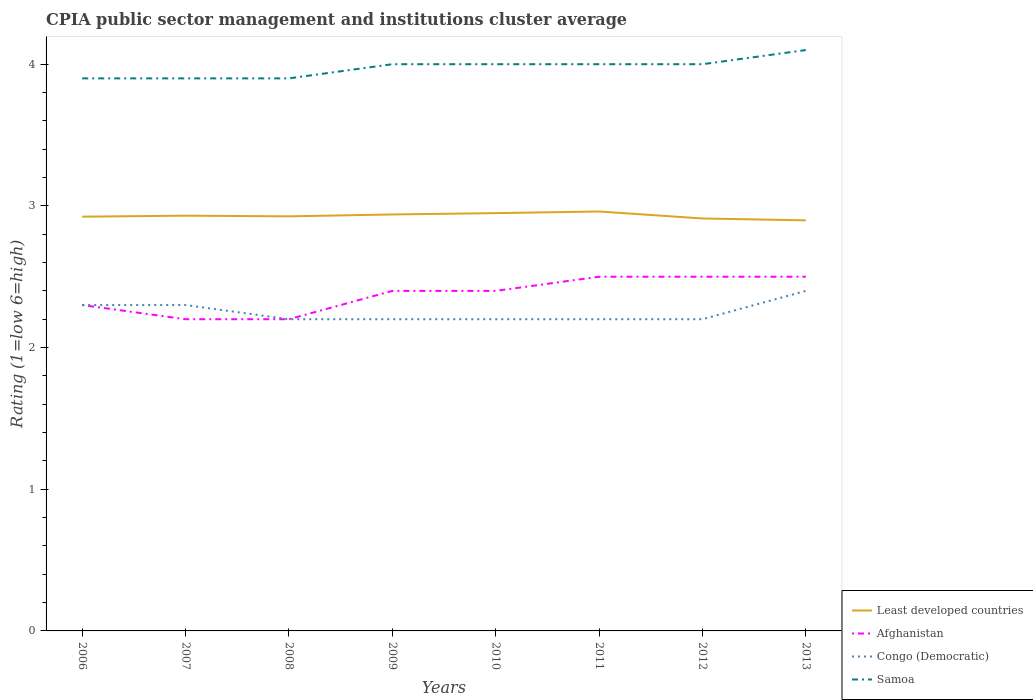How many different coloured lines are there?
Your response must be concise. 4. Is the number of lines equal to the number of legend labels?
Provide a succinct answer. Yes. Across all years, what is the maximum CPIA rating in Samoa?
Your answer should be compact. 3.9. In which year was the CPIA rating in Least developed countries maximum?
Make the answer very short. 2013. What is the total CPIA rating in Samoa in the graph?
Your answer should be very brief. -0.2. What is the difference between the highest and the second highest CPIA rating in Afghanistan?
Provide a short and direct response. 0.3. What is the difference between the highest and the lowest CPIA rating in Samoa?
Offer a very short reply. 5. Does the graph contain grids?
Keep it short and to the point. No. What is the title of the graph?
Keep it short and to the point. CPIA public sector management and institutions cluster average. Does "Kenya" appear as one of the legend labels in the graph?
Keep it short and to the point. No. What is the label or title of the X-axis?
Your response must be concise. Years. What is the label or title of the Y-axis?
Ensure brevity in your answer.  Rating (1=low 6=high). What is the Rating (1=low 6=high) in Least developed countries in 2006?
Your answer should be compact. 2.92. What is the Rating (1=low 6=high) in Afghanistan in 2006?
Offer a terse response. 2.3. What is the Rating (1=low 6=high) in Least developed countries in 2007?
Your response must be concise. 2.93. What is the Rating (1=low 6=high) of Afghanistan in 2007?
Make the answer very short. 2.2. What is the Rating (1=low 6=high) in Samoa in 2007?
Give a very brief answer. 3.9. What is the Rating (1=low 6=high) of Least developed countries in 2008?
Provide a succinct answer. 2.93. What is the Rating (1=low 6=high) of Afghanistan in 2008?
Provide a succinct answer. 2.2. What is the Rating (1=low 6=high) of Congo (Democratic) in 2008?
Your answer should be compact. 2.2. What is the Rating (1=low 6=high) in Samoa in 2008?
Offer a terse response. 3.9. What is the Rating (1=low 6=high) in Least developed countries in 2009?
Provide a short and direct response. 2.94. What is the Rating (1=low 6=high) in Afghanistan in 2009?
Give a very brief answer. 2.4. What is the Rating (1=low 6=high) of Samoa in 2009?
Ensure brevity in your answer.  4. What is the Rating (1=low 6=high) of Least developed countries in 2010?
Keep it short and to the point. 2.95. What is the Rating (1=low 6=high) of Afghanistan in 2010?
Make the answer very short. 2.4. What is the Rating (1=low 6=high) of Congo (Democratic) in 2010?
Your answer should be very brief. 2.2. What is the Rating (1=low 6=high) of Samoa in 2010?
Your answer should be compact. 4. What is the Rating (1=low 6=high) of Least developed countries in 2011?
Your answer should be very brief. 2.96. What is the Rating (1=low 6=high) of Least developed countries in 2012?
Offer a very short reply. 2.91. What is the Rating (1=low 6=high) in Congo (Democratic) in 2012?
Keep it short and to the point. 2.2. What is the Rating (1=low 6=high) of Least developed countries in 2013?
Provide a succinct answer. 2.9. What is the Rating (1=low 6=high) of Afghanistan in 2013?
Offer a terse response. 2.5. What is the Rating (1=low 6=high) in Congo (Democratic) in 2013?
Ensure brevity in your answer.  2.4. What is the Rating (1=low 6=high) in Samoa in 2013?
Your answer should be compact. 4.1. Across all years, what is the maximum Rating (1=low 6=high) of Least developed countries?
Make the answer very short. 2.96. Across all years, what is the maximum Rating (1=low 6=high) of Afghanistan?
Offer a terse response. 2.5. Across all years, what is the maximum Rating (1=low 6=high) in Congo (Democratic)?
Keep it short and to the point. 2.4. Across all years, what is the minimum Rating (1=low 6=high) of Least developed countries?
Give a very brief answer. 2.9. Across all years, what is the minimum Rating (1=low 6=high) in Congo (Democratic)?
Your answer should be compact. 2.2. Across all years, what is the minimum Rating (1=low 6=high) of Samoa?
Make the answer very short. 3.9. What is the total Rating (1=low 6=high) in Least developed countries in the graph?
Ensure brevity in your answer.  23.44. What is the total Rating (1=low 6=high) in Congo (Democratic) in the graph?
Your answer should be compact. 18. What is the total Rating (1=low 6=high) of Samoa in the graph?
Provide a succinct answer. 31.8. What is the difference between the Rating (1=low 6=high) of Least developed countries in 2006 and that in 2007?
Offer a terse response. -0.01. What is the difference between the Rating (1=low 6=high) of Samoa in 2006 and that in 2007?
Ensure brevity in your answer.  0. What is the difference between the Rating (1=low 6=high) in Least developed countries in 2006 and that in 2008?
Make the answer very short. -0. What is the difference between the Rating (1=low 6=high) of Afghanistan in 2006 and that in 2008?
Your answer should be compact. 0.1. What is the difference between the Rating (1=low 6=high) of Samoa in 2006 and that in 2008?
Provide a succinct answer. 0. What is the difference between the Rating (1=low 6=high) in Least developed countries in 2006 and that in 2009?
Ensure brevity in your answer.  -0.02. What is the difference between the Rating (1=low 6=high) of Samoa in 2006 and that in 2009?
Your response must be concise. -0.1. What is the difference between the Rating (1=low 6=high) in Least developed countries in 2006 and that in 2010?
Your response must be concise. -0.03. What is the difference between the Rating (1=low 6=high) in Congo (Democratic) in 2006 and that in 2010?
Provide a succinct answer. 0.1. What is the difference between the Rating (1=low 6=high) in Samoa in 2006 and that in 2010?
Offer a terse response. -0.1. What is the difference between the Rating (1=low 6=high) in Least developed countries in 2006 and that in 2011?
Provide a succinct answer. -0.04. What is the difference between the Rating (1=low 6=high) of Congo (Democratic) in 2006 and that in 2011?
Your answer should be compact. 0.1. What is the difference between the Rating (1=low 6=high) of Samoa in 2006 and that in 2011?
Your answer should be compact. -0.1. What is the difference between the Rating (1=low 6=high) of Least developed countries in 2006 and that in 2012?
Provide a short and direct response. 0.01. What is the difference between the Rating (1=low 6=high) of Congo (Democratic) in 2006 and that in 2012?
Your answer should be very brief. 0.1. What is the difference between the Rating (1=low 6=high) of Samoa in 2006 and that in 2012?
Make the answer very short. -0.1. What is the difference between the Rating (1=low 6=high) in Least developed countries in 2006 and that in 2013?
Your response must be concise. 0.03. What is the difference between the Rating (1=low 6=high) of Afghanistan in 2006 and that in 2013?
Make the answer very short. -0.2. What is the difference between the Rating (1=low 6=high) in Least developed countries in 2007 and that in 2008?
Ensure brevity in your answer.  0. What is the difference between the Rating (1=low 6=high) in Afghanistan in 2007 and that in 2008?
Make the answer very short. 0. What is the difference between the Rating (1=low 6=high) in Congo (Democratic) in 2007 and that in 2008?
Your answer should be compact. 0.1. What is the difference between the Rating (1=low 6=high) of Samoa in 2007 and that in 2008?
Keep it short and to the point. 0. What is the difference between the Rating (1=low 6=high) of Least developed countries in 2007 and that in 2009?
Offer a very short reply. -0.01. What is the difference between the Rating (1=low 6=high) of Congo (Democratic) in 2007 and that in 2009?
Your response must be concise. 0.1. What is the difference between the Rating (1=low 6=high) of Least developed countries in 2007 and that in 2010?
Offer a very short reply. -0.02. What is the difference between the Rating (1=low 6=high) of Afghanistan in 2007 and that in 2010?
Provide a succinct answer. -0.2. What is the difference between the Rating (1=low 6=high) of Least developed countries in 2007 and that in 2011?
Your answer should be very brief. -0.03. What is the difference between the Rating (1=low 6=high) of Congo (Democratic) in 2007 and that in 2011?
Your answer should be compact. 0.1. What is the difference between the Rating (1=low 6=high) in Samoa in 2007 and that in 2011?
Your answer should be compact. -0.1. What is the difference between the Rating (1=low 6=high) in Least developed countries in 2007 and that in 2012?
Make the answer very short. 0.02. What is the difference between the Rating (1=low 6=high) in Least developed countries in 2007 and that in 2013?
Offer a terse response. 0.03. What is the difference between the Rating (1=low 6=high) in Afghanistan in 2007 and that in 2013?
Keep it short and to the point. -0.3. What is the difference between the Rating (1=low 6=high) of Congo (Democratic) in 2007 and that in 2013?
Your response must be concise. -0.1. What is the difference between the Rating (1=low 6=high) in Samoa in 2007 and that in 2013?
Your response must be concise. -0.2. What is the difference between the Rating (1=low 6=high) of Least developed countries in 2008 and that in 2009?
Offer a very short reply. -0.01. What is the difference between the Rating (1=low 6=high) in Afghanistan in 2008 and that in 2009?
Give a very brief answer. -0.2. What is the difference between the Rating (1=low 6=high) of Samoa in 2008 and that in 2009?
Offer a terse response. -0.1. What is the difference between the Rating (1=low 6=high) in Least developed countries in 2008 and that in 2010?
Provide a short and direct response. -0.02. What is the difference between the Rating (1=low 6=high) of Congo (Democratic) in 2008 and that in 2010?
Offer a terse response. 0. What is the difference between the Rating (1=low 6=high) in Samoa in 2008 and that in 2010?
Your answer should be compact. -0.1. What is the difference between the Rating (1=low 6=high) of Least developed countries in 2008 and that in 2011?
Make the answer very short. -0.03. What is the difference between the Rating (1=low 6=high) of Least developed countries in 2008 and that in 2012?
Provide a succinct answer. 0.02. What is the difference between the Rating (1=low 6=high) of Afghanistan in 2008 and that in 2012?
Ensure brevity in your answer.  -0.3. What is the difference between the Rating (1=low 6=high) in Congo (Democratic) in 2008 and that in 2012?
Your response must be concise. 0. What is the difference between the Rating (1=low 6=high) in Least developed countries in 2008 and that in 2013?
Offer a terse response. 0.03. What is the difference between the Rating (1=low 6=high) in Afghanistan in 2008 and that in 2013?
Provide a short and direct response. -0.3. What is the difference between the Rating (1=low 6=high) in Samoa in 2008 and that in 2013?
Your response must be concise. -0.2. What is the difference between the Rating (1=low 6=high) of Least developed countries in 2009 and that in 2010?
Your answer should be compact. -0.01. What is the difference between the Rating (1=low 6=high) of Congo (Democratic) in 2009 and that in 2010?
Ensure brevity in your answer.  0. What is the difference between the Rating (1=low 6=high) of Least developed countries in 2009 and that in 2011?
Offer a very short reply. -0.02. What is the difference between the Rating (1=low 6=high) of Afghanistan in 2009 and that in 2011?
Your response must be concise. -0.1. What is the difference between the Rating (1=low 6=high) in Congo (Democratic) in 2009 and that in 2011?
Your answer should be very brief. 0. What is the difference between the Rating (1=low 6=high) in Least developed countries in 2009 and that in 2012?
Your answer should be compact. 0.03. What is the difference between the Rating (1=low 6=high) of Congo (Democratic) in 2009 and that in 2012?
Offer a terse response. 0. What is the difference between the Rating (1=low 6=high) of Least developed countries in 2009 and that in 2013?
Keep it short and to the point. 0.04. What is the difference between the Rating (1=low 6=high) in Congo (Democratic) in 2009 and that in 2013?
Give a very brief answer. -0.2. What is the difference between the Rating (1=low 6=high) of Least developed countries in 2010 and that in 2011?
Your answer should be very brief. -0.01. What is the difference between the Rating (1=low 6=high) in Samoa in 2010 and that in 2011?
Ensure brevity in your answer.  0. What is the difference between the Rating (1=low 6=high) in Least developed countries in 2010 and that in 2012?
Keep it short and to the point. 0.04. What is the difference between the Rating (1=low 6=high) in Afghanistan in 2010 and that in 2012?
Your answer should be very brief. -0.1. What is the difference between the Rating (1=low 6=high) in Congo (Democratic) in 2010 and that in 2012?
Keep it short and to the point. 0. What is the difference between the Rating (1=low 6=high) in Samoa in 2010 and that in 2012?
Your response must be concise. 0. What is the difference between the Rating (1=low 6=high) in Least developed countries in 2010 and that in 2013?
Make the answer very short. 0.05. What is the difference between the Rating (1=low 6=high) of Samoa in 2010 and that in 2013?
Make the answer very short. -0.1. What is the difference between the Rating (1=low 6=high) of Least developed countries in 2011 and that in 2012?
Offer a terse response. 0.05. What is the difference between the Rating (1=low 6=high) in Afghanistan in 2011 and that in 2012?
Provide a succinct answer. 0. What is the difference between the Rating (1=low 6=high) of Congo (Democratic) in 2011 and that in 2012?
Your response must be concise. 0. What is the difference between the Rating (1=low 6=high) in Samoa in 2011 and that in 2012?
Your answer should be compact. 0. What is the difference between the Rating (1=low 6=high) of Least developed countries in 2011 and that in 2013?
Provide a succinct answer. 0.06. What is the difference between the Rating (1=low 6=high) of Afghanistan in 2011 and that in 2013?
Make the answer very short. 0. What is the difference between the Rating (1=low 6=high) of Samoa in 2011 and that in 2013?
Your answer should be compact. -0.1. What is the difference between the Rating (1=low 6=high) of Least developed countries in 2012 and that in 2013?
Offer a terse response. 0.01. What is the difference between the Rating (1=low 6=high) of Afghanistan in 2012 and that in 2013?
Provide a short and direct response. 0. What is the difference between the Rating (1=low 6=high) in Congo (Democratic) in 2012 and that in 2013?
Your answer should be very brief. -0.2. What is the difference between the Rating (1=low 6=high) in Least developed countries in 2006 and the Rating (1=low 6=high) in Afghanistan in 2007?
Offer a very short reply. 0.72. What is the difference between the Rating (1=low 6=high) in Least developed countries in 2006 and the Rating (1=low 6=high) in Congo (Democratic) in 2007?
Offer a very short reply. 0.62. What is the difference between the Rating (1=low 6=high) of Least developed countries in 2006 and the Rating (1=low 6=high) of Samoa in 2007?
Give a very brief answer. -0.98. What is the difference between the Rating (1=low 6=high) of Congo (Democratic) in 2006 and the Rating (1=low 6=high) of Samoa in 2007?
Your response must be concise. -1.6. What is the difference between the Rating (1=low 6=high) in Least developed countries in 2006 and the Rating (1=low 6=high) in Afghanistan in 2008?
Give a very brief answer. 0.72. What is the difference between the Rating (1=low 6=high) in Least developed countries in 2006 and the Rating (1=low 6=high) in Congo (Democratic) in 2008?
Your response must be concise. 0.72. What is the difference between the Rating (1=low 6=high) in Least developed countries in 2006 and the Rating (1=low 6=high) in Samoa in 2008?
Your answer should be very brief. -0.98. What is the difference between the Rating (1=low 6=high) of Afghanistan in 2006 and the Rating (1=low 6=high) of Samoa in 2008?
Your answer should be very brief. -1.6. What is the difference between the Rating (1=low 6=high) of Least developed countries in 2006 and the Rating (1=low 6=high) of Afghanistan in 2009?
Give a very brief answer. 0.52. What is the difference between the Rating (1=low 6=high) of Least developed countries in 2006 and the Rating (1=low 6=high) of Congo (Democratic) in 2009?
Make the answer very short. 0.72. What is the difference between the Rating (1=low 6=high) of Least developed countries in 2006 and the Rating (1=low 6=high) of Samoa in 2009?
Offer a terse response. -1.08. What is the difference between the Rating (1=low 6=high) of Afghanistan in 2006 and the Rating (1=low 6=high) of Congo (Democratic) in 2009?
Keep it short and to the point. 0.1. What is the difference between the Rating (1=low 6=high) of Afghanistan in 2006 and the Rating (1=low 6=high) of Samoa in 2009?
Offer a terse response. -1.7. What is the difference between the Rating (1=low 6=high) in Congo (Democratic) in 2006 and the Rating (1=low 6=high) in Samoa in 2009?
Your answer should be compact. -1.7. What is the difference between the Rating (1=low 6=high) in Least developed countries in 2006 and the Rating (1=low 6=high) in Afghanistan in 2010?
Give a very brief answer. 0.52. What is the difference between the Rating (1=low 6=high) in Least developed countries in 2006 and the Rating (1=low 6=high) in Congo (Democratic) in 2010?
Provide a short and direct response. 0.72. What is the difference between the Rating (1=low 6=high) in Least developed countries in 2006 and the Rating (1=low 6=high) in Samoa in 2010?
Provide a succinct answer. -1.08. What is the difference between the Rating (1=low 6=high) in Afghanistan in 2006 and the Rating (1=low 6=high) in Congo (Democratic) in 2010?
Ensure brevity in your answer.  0.1. What is the difference between the Rating (1=low 6=high) of Afghanistan in 2006 and the Rating (1=low 6=high) of Samoa in 2010?
Your answer should be compact. -1.7. What is the difference between the Rating (1=low 6=high) of Congo (Democratic) in 2006 and the Rating (1=low 6=high) of Samoa in 2010?
Offer a very short reply. -1.7. What is the difference between the Rating (1=low 6=high) of Least developed countries in 2006 and the Rating (1=low 6=high) of Afghanistan in 2011?
Make the answer very short. 0.42. What is the difference between the Rating (1=low 6=high) in Least developed countries in 2006 and the Rating (1=low 6=high) in Congo (Democratic) in 2011?
Your answer should be compact. 0.72. What is the difference between the Rating (1=low 6=high) in Least developed countries in 2006 and the Rating (1=low 6=high) in Samoa in 2011?
Ensure brevity in your answer.  -1.08. What is the difference between the Rating (1=low 6=high) of Afghanistan in 2006 and the Rating (1=low 6=high) of Congo (Democratic) in 2011?
Provide a short and direct response. 0.1. What is the difference between the Rating (1=low 6=high) in Afghanistan in 2006 and the Rating (1=low 6=high) in Samoa in 2011?
Offer a terse response. -1.7. What is the difference between the Rating (1=low 6=high) of Least developed countries in 2006 and the Rating (1=low 6=high) of Afghanistan in 2012?
Make the answer very short. 0.42. What is the difference between the Rating (1=low 6=high) in Least developed countries in 2006 and the Rating (1=low 6=high) in Congo (Democratic) in 2012?
Offer a terse response. 0.72. What is the difference between the Rating (1=low 6=high) in Least developed countries in 2006 and the Rating (1=low 6=high) in Samoa in 2012?
Provide a short and direct response. -1.08. What is the difference between the Rating (1=low 6=high) in Afghanistan in 2006 and the Rating (1=low 6=high) in Congo (Democratic) in 2012?
Your response must be concise. 0.1. What is the difference between the Rating (1=low 6=high) of Least developed countries in 2006 and the Rating (1=low 6=high) of Afghanistan in 2013?
Your answer should be very brief. 0.42. What is the difference between the Rating (1=low 6=high) in Least developed countries in 2006 and the Rating (1=low 6=high) in Congo (Democratic) in 2013?
Provide a short and direct response. 0.52. What is the difference between the Rating (1=low 6=high) in Least developed countries in 2006 and the Rating (1=low 6=high) in Samoa in 2013?
Make the answer very short. -1.18. What is the difference between the Rating (1=low 6=high) of Afghanistan in 2006 and the Rating (1=low 6=high) of Congo (Democratic) in 2013?
Offer a terse response. -0.1. What is the difference between the Rating (1=low 6=high) in Afghanistan in 2006 and the Rating (1=low 6=high) in Samoa in 2013?
Your response must be concise. -1.8. What is the difference between the Rating (1=low 6=high) in Congo (Democratic) in 2006 and the Rating (1=low 6=high) in Samoa in 2013?
Keep it short and to the point. -1.8. What is the difference between the Rating (1=low 6=high) of Least developed countries in 2007 and the Rating (1=low 6=high) of Afghanistan in 2008?
Your answer should be compact. 0.73. What is the difference between the Rating (1=low 6=high) in Least developed countries in 2007 and the Rating (1=low 6=high) in Congo (Democratic) in 2008?
Your response must be concise. 0.73. What is the difference between the Rating (1=low 6=high) of Least developed countries in 2007 and the Rating (1=low 6=high) of Samoa in 2008?
Ensure brevity in your answer.  -0.97. What is the difference between the Rating (1=low 6=high) in Afghanistan in 2007 and the Rating (1=low 6=high) in Samoa in 2008?
Ensure brevity in your answer.  -1.7. What is the difference between the Rating (1=low 6=high) in Congo (Democratic) in 2007 and the Rating (1=low 6=high) in Samoa in 2008?
Your answer should be compact. -1.6. What is the difference between the Rating (1=low 6=high) in Least developed countries in 2007 and the Rating (1=low 6=high) in Afghanistan in 2009?
Your answer should be very brief. 0.53. What is the difference between the Rating (1=low 6=high) of Least developed countries in 2007 and the Rating (1=low 6=high) of Congo (Democratic) in 2009?
Offer a very short reply. 0.73. What is the difference between the Rating (1=low 6=high) of Least developed countries in 2007 and the Rating (1=low 6=high) of Samoa in 2009?
Provide a succinct answer. -1.07. What is the difference between the Rating (1=low 6=high) of Afghanistan in 2007 and the Rating (1=low 6=high) of Congo (Democratic) in 2009?
Offer a very short reply. 0. What is the difference between the Rating (1=low 6=high) of Afghanistan in 2007 and the Rating (1=low 6=high) of Samoa in 2009?
Ensure brevity in your answer.  -1.8. What is the difference between the Rating (1=low 6=high) of Least developed countries in 2007 and the Rating (1=low 6=high) of Afghanistan in 2010?
Your answer should be very brief. 0.53. What is the difference between the Rating (1=low 6=high) in Least developed countries in 2007 and the Rating (1=low 6=high) in Congo (Democratic) in 2010?
Give a very brief answer. 0.73. What is the difference between the Rating (1=low 6=high) of Least developed countries in 2007 and the Rating (1=low 6=high) of Samoa in 2010?
Give a very brief answer. -1.07. What is the difference between the Rating (1=low 6=high) in Afghanistan in 2007 and the Rating (1=low 6=high) in Samoa in 2010?
Offer a terse response. -1.8. What is the difference between the Rating (1=low 6=high) in Congo (Democratic) in 2007 and the Rating (1=low 6=high) in Samoa in 2010?
Your answer should be very brief. -1.7. What is the difference between the Rating (1=low 6=high) of Least developed countries in 2007 and the Rating (1=low 6=high) of Afghanistan in 2011?
Your answer should be compact. 0.43. What is the difference between the Rating (1=low 6=high) in Least developed countries in 2007 and the Rating (1=low 6=high) in Congo (Democratic) in 2011?
Your answer should be compact. 0.73. What is the difference between the Rating (1=low 6=high) in Least developed countries in 2007 and the Rating (1=low 6=high) in Samoa in 2011?
Provide a succinct answer. -1.07. What is the difference between the Rating (1=low 6=high) in Afghanistan in 2007 and the Rating (1=low 6=high) in Congo (Democratic) in 2011?
Your response must be concise. 0. What is the difference between the Rating (1=low 6=high) in Afghanistan in 2007 and the Rating (1=low 6=high) in Samoa in 2011?
Ensure brevity in your answer.  -1.8. What is the difference between the Rating (1=low 6=high) of Least developed countries in 2007 and the Rating (1=low 6=high) of Afghanistan in 2012?
Offer a terse response. 0.43. What is the difference between the Rating (1=low 6=high) of Least developed countries in 2007 and the Rating (1=low 6=high) of Congo (Democratic) in 2012?
Your response must be concise. 0.73. What is the difference between the Rating (1=low 6=high) in Least developed countries in 2007 and the Rating (1=low 6=high) in Samoa in 2012?
Your response must be concise. -1.07. What is the difference between the Rating (1=low 6=high) of Afghanistan in 2007 and the Rating (1=low 6=high) of Samoa in 2012?
Make the answer very short. -1.8. What is the difference between the Rating (1=low 6=high) in Congo (Democratic) in 2007 and the Rating (1=low 6=high) in Samoa in 2012?
Give a very brief answer. -1.7. What is the difference between the Rating (1=low 6=high) of Least developed countries in 2007 and the Rating (1=low 6=high) of Afghanistan in 2013?
Give a very brief answer. 0.43. What is the difference between the Rating (1=low 6=high) of Least developed countries in 2007 and the Rating (1=low 6=high) of Congo (Democratic) in 2013?
Offer a terse response. 0.53. What is the difference between the Rating (1=low 6=high) of Least developed countries in 2007 and the Rating (1=low 6=high) of Samoa in 2013?
Give a very brief answer. -1.17. What is the difference between the Rating (1=low 6=high) in Afghanistan in 2007 and the Rating (1=low 6=high) in Congo (Democratic) in 2013?
Make the answer very short. -0.2. What is the difference between the Rating (1=low 6=high) in Least developed countries in 2008 and the Rating (1=low 6=high) in Afghanistan in 2009?
Make the answer very short. 0.53. What is the difference between the Rating (1=low 6=high) in Least developed countries in 2008 and the Rating (1=low 6=high) in Congo (Democratic) in 2009?
Give a very brief answer. 0.73. What is the difference between the Rating (1=low 6=high) in Least developed countries in 2008 and the Rating (1=low 6=high) in Samoa in 2009?
Offer a terse response. -1.07. What is the difference between the Rating (1=low 6=high) of Afghanistan in 2008 and the Rating (1=low 6=high) of Congo (Democratic) in 2009?
Your answer should be very brief. 0. What is the difference between the Rating (1=low 6=high) of Least developed countries in 2008 and the Rating (1=low 6=high) of Afghanistan in 2010?
Ensure brevity in your answer.  0.53. What is the difference between the Rating (1=low 6=high) of Least developed countries in 2008 and the Rating (1=low 6=high) of Congo (Democratic) in 2010?
Your answer should be compact. 0.73. What is the difference between the Rating (1=low 6=high) in Least developed countries in 2008 and the Rating (1=low 6=high) in Samoa in 2010?
Give a very brief answer. -1.07. What is the difference between the Rating (1=low 6=high) of Afghanistan in 2008 and the Rating (1=low 6=high) of Congo (Democratic) in 2010?
Your answer should be very brief. 0. What is the difference between the Rating (1=low 6=high) in Least developed countries in 2008 and the Rating (1=low 6=high) in Afghanistan in 2011?
Your response must be concise. 0.43. What is the difference between the Rating (1=low 6=high) of Least developed countries in 2008 and the Rating (1=low 6=high) of Congo (Democratic) in 2011?
Provide a succinct answer. 0.73. What is the difference between the Rating (1=low 6=high) of Least developed countries in 2008 and the Rating (1=low 6=high) of Samoa in 2011?
Provide a succinct answer. -1.07. What is the difference between the Rating (1=low 6=high) of Afghanistan in 2008 and the Rating (1=low 6=high) of Congo (Democratic) in 2011?
Your answer should be very brief. 0. What is the difference between the Rating (1=low 6=high) in Least developed countries in 2008 and the Rating (1=low 6=high) in Afghanistan in 2012?
Ensure brevity in your answer.  0.43. What is the difference between the Rating (1=low 6=high) in Least developed countries in 2008 and the Rating (1=low 6=high) in Congo (Democratic) in 2012?
Provide a short and direct response. 0.73. What is the difference between the Rating (1=low 6=high) of Least developed countries in 2008 and the Rating (1=low 6=high) of Samoa in 2012?
Offer a very short reply. -1.07. What is the difference between the Rating (1=low 6=high) in Afghanistan in 2008 and the Rating (1=low 6=high) in Congo (Democratic) in 2012?
Ensure brevity in your answer.  0. What is the difference between the Rating (1=low 6=high) in Congo (Democratic) in 2008 and the Rating (1=low 6=high) in Samoa in 2012?
Provide a succinct answer. -1.8. What is the difference between the Rating (1=low 6=high) in Least developed countries in 2008 and the Rating (1=low 6=high) in Afghanistan in 2013?
Ensure brevity in your answer.  0.43. What is the difference between the Rating (1=low 6=high) in Least developed countries in 2008 and the Rating (1=low 6=high) in Congo (Democratic) in 2013?
Your answer should be very brief. 0.53. What is the difference between the Rating (1=low 6=high) of Least developed countries in 2008 and the Rating (1=low 6=high) of Samoa in 2013?
Your answer should be compact. -1.17. What is the difference between the Rating (1=low 6=high) of Least developed countries in 2009 and the Rating (1=low 6=high) of Afghanistan in 2010?
Give a very brief answer. 0.54. What is the difference between the Rating (1=low 6=high) in Least developed countries in 2009 and the Rating (1=low 6=high) in Congo (Democratic) in 2010?
Provide a short and direct response. 0.74. What is the difference between the Rating (1=low 6=high) in Least developed countries in 2009 and the Rating (1=low 6=high) in Samoa in 2010?
Make the answer very short. -1.06. What is the difference between the Rating (1=low 6=high) in Afghanistan in 2009 and the Rating (1=low 6=high) in Samoa in 2010?
Offer a very short reply. -1.6. What is the difference between the Rating (1=low 6=high) in Least developed countries in 2009 and the Rating (1=low 6=high) in Afghanistan in 2011?
Provide a short and direct response. 0.44. What is the difference between the Rating (1=low 6=high) of Least developed countries in 2009 and the Rating (1=low 6=high) of Congo (Democratic) in 2011?
Your answer should be compact. 0.74. What is the difference between the Rating (1=low 6=high) of Least developed countries in 2009 and the Rating (1=low 6=high) of Samoa in 2011?
Provide a short and direct response. -1.06. What is the difference between the Rating (1=low 6=high) of Least developed countries in 2009 and the Rating (1=low 6=high) of Afghanistan in 2012?
Keep it short and to the point. 0.44. What is the difference between the Rating (1=low 6=high) in Least developed countries in 2009 and the Rating (1=low 6=high) in Congo (Democratic) in 2012?
Keep it short and to the point. 0.74. What is the difference between the Rating (1=low 6=high) of Least developed countries in 2009 and the Rating (1=low 6=high) of Samoa in 2012?
Your answer should be compact. -1.06. What is the difference between the Rating (1=low 6=high) of Afghanistan in 2009 and the Rating (1=low 6=high) of Congo (Democratic) in 2012?
Make the answer very short. 0.2. What is the difference between the Rating (1=low 6=high) in Congo (Democratic) in 2009 and the Rating (1=low 6=high) in Samoa in 2012?
Ensure brevity in your answer.  -1.8. What is the difference between the Rating (1=low 6=high) in Least developed countries in 2009 and the Rating (1=low 6=high) in Afghanistan in 2013?
Offer a terse response. 0.44. What is the difference between the Rating (1=low 6=high) of Least developed countries in 2009 and the Rating (1=low 6=high) of Congo (Democratic) in 2013?
Keep it short and to the point. 0.54. What is the difference between the Rating (1=low 6=high) of Least developed countries in 2009 and the Rating (1=low 6=high) of Samoa in 2013?
Your response must be concise. -1.16. What is the difference between the Rating (1=low 6=high) in Afghanistan in 2009 and the Rating (1=low 6=high) in Samoa in 2013?
Keep it short and to the point. -1.7. What is the difference between the Rating (1=low 6=high) in Least developed countries in 2010 and the Rating (1=low 6=high) in Afghanistan in 2011?
Offer a very short reply. 0.45. What is the difference between the Rating (1=low 6=high) in Least developed countries in 2010 and the Rating (1=low 6=high) in Congo (Democratic) in 2011?
Ensure brevity in your answer.  0.75. What is the difference between the Rating (1=low 6=high) in Least developed countries in 2010 and the Rating (1=low 6=high) in Samoa in 2011?
Provide a short and direct response. -1.05. What is the difference between the Rating (1=low 6=high) of Afghanistan in 2010 and the Rating (1=low 6=high) of Congo (Democratic) in 2011?
Provide a succinct answer. 0.2. What is the difference between the Rating (1=low 6=high) in Least developed countries in 2010 and the Rating (1=low 6=high) in Afghanistan in 2012?
Your answer should be very brief. 0.45. What is the difference between the Rating (1=low 6=high) of Least developed countries in 2010 and the Rating (1=low 6=high) of Congo (Democratic) in 2012?
Ensure brevity in your answer.  0.75. What is the difference between the Rating (1=low 6=high) of Least developed countries in 2010 and the Rating (1=low 6=high) of Samoa in 2012?
Ensure brevity in your answer.  -1.05. What is the difference between the Rating (1=low 6=high) in Afghanistan in 2010 and the Rating (1=low 6=high) in Congo (Democratic) in 2012?
Keep it short and to the point. 0.2. What is the difference between the Rating (1=low 6=high) in Congo (Democratic) in 2010 and the Rating (1=low 6=high) in Samoa in 2012?
Give a very brief answer. -1.8. What is the difference between the Rating (1=low 6=high) in Least developed countries in 2010 and the Rating (1=low 6=high) in Afghanistan in 2013?
Provide a short and direct response. 0.45. What is the difference between the Rating (1=low 6=high) in Least developed countries in 2010 and the Rating (1=low 6=high) in Congo (Democratic) in 2013?
Provide a short and direct response. 0.55. What is the difference between the Rating (1=low 6=high) in Least developed countries in 2010 and the Rating (1=low 6=high) in Samoa in 2013?
Offer a very short reply. -1.15. What is the difference between the Rating (1=low 6=high) in Congo (Democratic) in 2010 and the Rating (1=low 6=high) in Samoa in 2013?
Keep it short and to the point. -1.9. What is the difference between the Rating (1=low 6=high) of Least developed countries in 2011 and the Rating (1=low 6=high) of Afghanistan in 2012?
Offer a terse response. 0.46. What is the difference between the Rating (1=low 6=high) of Least developed countries in 2011 and the Rating (1=low 6=high) of Congo (Democratic) in 2012?
Ensure brevity in your answer.  0.76. What is the difference between the Rating (1=low 6=high) of Least developed countries in 2011 and the Rating (1=low 6=high) of Samoa in 2012?
Ensure brevity in your answer.  -1.04. What is the difference between the Rating (1=low 6=high) of Afghanistan in 2011 and the Rating (1=low 6=high) of Samoa in 2012?
Your answer should be very brief. -1.5. What is the difference between the Rating (1=low 6=high) in Congo (Democratic) in 2011 and the Rating (1=low 6=high) in Samoa in 2012?
Keep it short and to the point. -1.8. What is the difference between the Rating (1=low 6=high) in Least developed countries in 2011 and the Rating (1=low 6=high) in Afghanistan in 2013?
Offer a very short reply. 0.46. What is the difference between the Rating (1=low 6=high) in Least developed countries in 2011 and the Rating (1=low 6=high) in Congo (Democratic) in 2013?
Provide a succinct answer. 0.56. What is the difference between the Rating (1=low 6=high) in Least developed countries in 2011 and the Rating (1=low 6=high) in Samoa in 2013?
Make the answer very short. -1.14. What is the difference between the Rating (1=low 6=high) of Afghanistan in 2011 and the Rating (1=low 6=high) of Congo (Democratic) in 2013?
Keep it short and to the point. 0.1. What is the difference between the Rating (1=low 6=high) of Afghanistan in 2011 and the Rating (1=low 6=high) of Samoa in 2013?
Offer a terse response. -1.6. What is the difference between the Rating (1=low 6=high) in Least developed countries in 2012 and the Rating (1=low 6=high) in Afghanistan in 2013?
Offer a very short reply. 0.41. What is the difference between the Rating (1=low 6=high) of Least developed countries in 2012 and the Rating (1=low 6=high) of Congo (Democratic) in 2013?
Your response must be concise. 0.51. What is the difference between the Rating (1=low 6=high) of Least developed countries in 2012 and the Rating (1=low 6=high) of Samoa in 2013?
Provide a short and direct response. -1.19. What is the difference between the Rating (1=low 6=high) of Afghanistan in 2012 and the Rating (1=low 6=high) of Congo (Democratic) in 2013?
Keep it short and to the point. 0.1. What is the average Rating (1=low 6=high) of Least developed countries per year?
Your response must be concise. 2.93. What is the average Rating (1=low 6=high) of Afghanistan per year?
Offer a terse response. 2.38. What is the average Rating (1=low 6=high) of Congo (Democratic) per year?
Provide a short and direct response. 2.25. What is the average Rating (1=low 6=high) in Samoa per year?
Ensure brevity in your answer.  3.98. In the year 2006, what is the difference between the Rating (1=low 6=high) of Least developed countries and Rating (1=low 6=high) of Afghanistan?
Keep it short and to the point. 0.62. In the year 2006, what is the difference between the Rating (1=low 6=high) in Least developed countries and Rating (1=low 6=high) in Congo (Democratic)?
Your answer should be very brief. 0.62. In the year 2006, what is the difference between the Rating (1=low 6=high) of Least developed countries and Rating (1=low 6=high) of Samoa?
Offer a very short reply. -0.98. In the year 2007, what is the difference between the Rating (1=low 6=high) of Least developed countries and Rating (1=low 6=high) of Afghanistan?
Give a very brief answer. 0.73. In the year 2007, what is the difference between the Rating (1=low 6=high) of Least developed countries and Rating (1=low 6=high) of Congo (Democratic)?
Your answer should be very brief. 0.63. In the year 2007, what is the difference between the Rating (1=low 6=high) of Least developed countries and Rating (1=low 6=high) of Samoa?
Your answer should be very brief. -0.97. In the year 2008, what is the difference between the Rating (1=low 6=high) in Least developed countries and Rating (1=low 6=high) in Afghanistan?
Offer a terse response. 0.73. In the year 2008, what is the difference between the Rating (1=low 6=high) in Least developed countries and Rating (1=low 6=high) in Congo (Democratic)?
Offer a very short reply. 0.73. In the year 2008, what is the difference between the Rating (1=low 6=high) in Least developed countries and Rating (1=low 6=high) in Samoa?
Offer a very short reply. -0.97. In the year 2009, what is the difference between the Rating (1=low 6=high) of Least developed countries and Rating (1=low 6=high) of Afghanistan?
Offer a very short reply. 0.54. In the year 2009, what is the difference between the Rating (1=low 6=high) in Least developed countries and Rating (1=low 6=high) in Congo (Democratic)?
Your answer should be very brief. 0.74. In the year 2009, what is the difference between the Rating (1=low 6=high) of Least developed countries and Rating (1=low 6=high) of Samoa?
Ensure brevity in your answer.  -1.06. In the year 2009, what is the difference between the Rating (1=low 6=high) of Afghanistan and Rating (1=low 6=high) of Congo (Democratic)?
Keep it short and to the point. 0.2. In the year 2010, what is the difference between the Rating (1=low 6=high) in Least developed countries and Rating (1=low 6=high) in Afghanistan?
Give a very brief answer. 0.55. In the year 2010, what is the difference between the Rating (1=low 6=high) in Least developed countries and Rating (1=low 6=high) in Congo (Democratic)?
Keep it short and to the point. 0.75. In the year 2010, what is the difference between the Rating (1=low 6=high) in Least developed countries and Rating (1=low 6=high) in Samoa?
Provide a short and direct response. -1.05. In the year 2011, what is the difference between the Rating (1=low 6=high) of Least developed countries and Rating (1=low 6=high) of Afghanistan?
Your response must be concise. 0.46. In the year 2011, what is the difference between the Rating (1=low 6=high) in Least developed countries and Rating (1=low 6=high) in Congo (Democratic)?
Keep it short and to the point. 0.76. In the year 2011, what is the difference between the Rating (1=low 6=high) of Least developed countries and Rating (1=low 6=high) of Samoa?
Provide a short and direct response. -1.04. In the year 2011, what is the difference between the Rating (1=low 6=high) of Afghanistan and Rating (1=low 6=high) of Samoa?
Give a very brief answer. -1.5. In the year 2012, what is the difference between the Rating (1=low 6=high) of Least developed countries and Rating (1=low 6=high) of Afghanistan?
Offer a very short reply. 0.41. In the year 2012, what is the difference between the Rating (1=low 6=high) in Least developed countries and Rating (1=low 6=high) in Congo (Democratic)?
Provide a succinct answer. 0.71. In the year 2012, what is the difference between the Rating (1=low 6=high) in Least developed countries and Rating (1=low 6=high) in Samoa?
Your answer should be compact. -1.09. In the year 2012, what is the difference between the Rating (1=low 6=high) of Congo (Democratic) and Rating (1=low 6=high) of Samoa?
Your response must be concise. -1.8. In the year 2013, what is the difference between the Rating (1=low 6=high) in Least developed countries and Rating (1=low 6=high) in Afghanistan?
Give a very brief answer. 0.4. In the year 2013, what is the difference between the Rating (1=low 6=high) in Least developed countries and Rating (1=low 6=high) in Congo (Democratic)?
Make the answer very short. 0.5. In the year 2013, what is the difference between the Rating (1=low 6=high) of Least developed countries and Rating (1=low 6=high) of Samoa?
Your response must be concise. -1.2. In the year 2013, what is the difference between the Rating (1=low 6=high) in Afghanistan and Rating (1=low 6=high) in Samoa?
Your answer should be very brief. -1.6. In the year 2013, what is the difference between the Rating (1=low 6=high) of Congo (Democratic) and Rating (1=low 6=high) of Samoa?
Give a very brief answer. -1.7. What is the ratio of the Rating (1=low 6=high) of Afghanistan in 2006 to that in 2007?
Provide a short and direct response. 1.05. What is the ratio of the Rating (1=low 6=high) in Congo (Democratic) in 2006 to that in 2007?
Give a very brief answer. 1. What is the ratio of the Rating (1=low 6=high) of Samoa in 2006 to that in 2007?
Keep it short and to the point. 1. What is the ratio of the Rating (1=low 6=high) in Least developed countries in 2006 to that in 2008?
Ensure brevity in your answer.  1. What is the ratio of the Rating (1=low 6=high) in Afghanistan in 2006 to that in 2008?
Offer a terse response. 1.05. What is the ratio of the Rating (1=low 6=high) of Congo (Democratic) in 2006 to that in 2008?
Provide a short and direct response. 1.05. What is the ratio of the Rating (1=low 6=high) of Least developed countries in 2006 to that in 2009?
Give a very brief answer. 0.99. What is the ratio of the Rating (1=low 6=high) in Congo (Democratic) in 2006 to that in 2009?
Make the answer very short. 1.05. What is the ratio of the Rating (1=low 6=high) in Afghanistan in 2006 to that in 2010?
Give a very brief answer. 0.96. What is the ratio of the Rating (1=low 6=high) of Congo (Democratic) in 2006 to that in 2010?
Offer a very short reply. 1.05. What is the ratio of the Rating (1=low 6=high) in Samoa in 2006 to that in 2010?
Your response must be concise. 0.97. What is the ratio of the Rating (1=low 6=high) in Least developed countries in 2006 to that in 2011?
Your answer should be compact. 0.99. What is the ratio of the Rating (1=low 6=high) of Congo (Democratic) in 2006 to that in 2011?
Give a very brief answer. 1.05. What is the ratio of the Rating (1=low 6=high) in Samoa in 2006 to that in 2011?
Your response must be concise. 0.97. What is the ratio of the Rating (1=low 6=high) of Afghanistan in 2006 to that in 2012?
Provide a short and direct response. 0.92. What is the ratio of the Rating (1=low 6=high) in Congo (Democratic) in 2006 to that in 2012?
Give a very brief answer. 1.05. What is the ratio of the Rating (1=low 6=high) of Samoa in 2006 to that in 2012?
Your response must be concise. 0.97. What is the ratio of the Rating (1=low 6=high) of Least developed countries in 2006 to that in 2013?
Offer a very short reply. 1.01. What is the ratio of the Rating (1=low 6=high) in Congo (Democratic) in 2006 to that in 2013?
Give a very brief answer. 0.96. What is the ratio of the Rating (1=low 6=high) of Samoa in 2006 to that in 2013?
Your answer should be very brief. 0.95. What is the ratio of the Rating (1=low 6=high) in Congo (Democratic) in 2007 to that in 2008?
Give a very brief answer. 1.05. What is the ratio of the Rating (1=low 6=high) in Least developed countries in 2007 to that in 2009?
Ensure brevity in your answer.  1. What is the ratio of the Rating (1=low 6=high) in Afghanistan in 2007 to that in 2009?
Make the answer very short. 0.92. What is the ratio of the Rating (1=low 6=high) in Congo (Democratic) in 2007 to that in 2009?
Provide a short and direct response. 1.05. What is the ratio of the Rating (1=low 6=high) in Afghanistan in 2007 to that in 2010?
Provide a succinct answer. 0.92. What is the ratio of the Rating (1=low 6=high) of Congo (Democratic) in 2007 to that in 2010?
Offer a terse response. 1.05. What is the ratio of the Rating (1=low 6=high) of Samoa in 2007 to that in 2010?
Your answer should be compact. 0.97. What is the ratio of the Rating (1=low 6=high) of Congo (Democratic) in 2007 to that in 2011?
Keep it short and to the point. 1.05. What is the ratio of the Rating (1=low 6=high) of Least developed countries in 2007 to that in 2012?
Give a very brief answer. 1.01. What is the ratio of the Rating (1=low 6=high) of Afghanistan in 2007 to that in 2012?
Make the answer very short. 0.88. What is the ratio of the Rating (1=low 6=high) of Congo (Democratic) in 2007 to that in 2012?
Your answer should be very brief. 1.05. What is the ratio of the Rating (1=low 6=high) of Samoa in 2007 to that in 2012?
Give a very brief answer. 0.97. What is the ratio of the Rating (1=low 6=high) in Least developed countries in 2007 to that in 2013?
Give a very brief answer. 1.01. What is the ratio of the Rating (1=low 6=high) of Samoa in 2007 to that in 2013?
Provide a succinct answer. 0.95. What is the ratio of the Rating (1=low 6=high) of Least developed countries in 2008 to that in 2009?
Keep it short and to the point. 1. What is the ratio of the Rating (1=low 6=high) of Afghanistan in 2008 to that in 2009?
Offer a terse response. 0.92. What is the ratio of the Rating (1=low 6=high) of Congo (Democratic) in 2008 to that in 2009?
Offer a terse response. 1. What is the ratio of the Rating (1=low 6=high) in Afghanistan in 2008 to that in 2010?
Keep it short and to the point. 0.92. What is the ratio of the Rating (1=low 6=high) in Congo (Democratic) in 2008 to that in 2010?
Ensure brevity in your answer.  1. What is the ratio of the Rating (1=low 6=high) of Samoa in 2008 to that in 2010?
Your response must be concise. 0.97. What is the ratio of the Rating (1=low 6=high) of Least developed countries in 2008 to that in 2011?
Make the answer very short. 0.99. What is the ratio of the Rating (1=low 6=high) in Congo (Democratic) in 2008 to that in 2011?
Provide a short and direct response. 1. What is the ratio of the Rating (1=low 6=high) in Congo (Democratic) in 2008 to that in 2012?
Make the answer very short. 1. What is the ratio of the Rating (1=low 6=high) in Samoa in 2008 to that in 2012?
Provide a succinct answer. 0.97. What is the ratio of the Rating (1=low 6=high) of Least developed countries in 2008 to that in 2013?
Your answer should be compact. 1.01. What is the ratio of the Rating (1=low 6=high) of Afghanistan in 2008 to that in 2013?
Offer a terse response. 0.88. What is the ratio of the Rating (1=low 6=high) in Samoa in 2008 to that in 2013?
Your answer should be very brief. 0.95. What is the ratio of the Rating (1=low 6=high) of Congo (Democratic) in 2009 to that in 2010?
Provide a short and direct response. 1. What is the ratio of the Rating (1=low 6=high) of Least developed countries in 2009 to that in 2011?
Offer a very short reply. 0.99. What is the ratio of the Rating (1=low 6=high) of Afghanistan in 2009 to that in 2011?
Offer a terse response. 0.96. What is the ratio of the Rating (1=low 6=high) of Samoa in 2009 to that in 2011?
Your answer should be very brief. 1. What is the ratio of the Rating (1=low 6=high) in Least developed countries in 2009 to that in 2012?
Your response must be concise. 1.01. What is the ratio of the Rating (1=low 6=high) of Congo (Democratic) in 2009 to that in 2012?
Provide a short and direct response. 1. What is the ratio of the Rating (1=low 6=high) of Least developed countries in 2009 to that in 2013?
Ensure brevity in your answer.  1.01. What is the ratio of the Rating (1=low 6=high) of Congo (Democratic) in 2009 to that in 2013?
Your response must be concise. 0.92. What is the ratio of the Rating (1=low 6=high) in Samoa in 2009 to that in 2013?
Your answer should be very brief. 0.98. What is the ratio of the Rating (1=low 6=high) in Congo (Democratic) in 2010 to that in 2011?
Provide a short and direct response. 1. What is the ratio of the Rating (1=low 6=high) of Samoa in 2010 to that in 2011?
Ensure brevity in your answer.  1. What is the ratio of the Rating (1=low 6=high) of Afghanistan in 2010 to that in 2012?
Make the answer very short. 0.96. What is the ratio of the Rating (1=low 6=high) of Least developed countries in 2010 to that in 2013?
Provide a short and direct response. 1.02. What is the ratio of the Rating (1=low 6=high) in Afghanistan in 2010 to that in 2013?
Offer a terse response. 0.96. What is the ratio of the Rating (1=low 6=high) of Congo (Democratic) in 2010 to that in 2013?
Ensure brevity in your answer.  0.92. What is the ratio of the Rating (1=low 6=high) of Samoa in 2010 to that in 2013?
Ensure brevity in your answer.  0.98. What is the ratio of the Rating (1=low 6=high) in Least developed countries in 2011 to that in 2012?
Offer a terse response. 1.02. What is the ratio of the Rating (1=low 6=high) of Afghanistan in 2011 to that in 2012?
Make the answer very short. 1. What is the ratio of the Rating (1=low 6=high) in Congo (Democratic) in 2011 to that in 2012?
Provide a short and direct response. 1. What is the ratio of the Rating (1=low 6=high) in Samoa in 2011 to that in 2012?
Keep it short and to the point. 1. What is the ratio of the Rating (1=low 6=high) of Least developed countries in 2011 to that in 2013?
Ensure brevity in your answer.  1.02. What is the ratio of the Rating (1=low 6=high) of Samoa in 2011 to that in 2013?
Keep it short and to the point. 0.98. What is the ratio of the Rating (1=low 6=high) in Afghanistan in 2012 to that in 2013?
Ensure brevity in your answer.  1. What is the ratio of the Rating (1=low 6=high) in Samoa in 2012 to that in 2013?
Provide a short and direct response. 0.98. What is the difference between the highest and the second highest Rating (1=low 6=high) in Least developed countries?
Your answer should be very brief. 0.01. What is the difference between the highest and the second highest Rating (1=low 6=high) in Afghanistan?
Your response must be concise. 0. What is the difference between the highest and the second highest Rating (1=low 6=high) in Samoa?
Your response must be concise. 0.1. What is the difference between the highest and the lowest Rating (1=low 6=high) in Least developed countries?
Offer a very short reply. 0.06. What is the difference between the highest and the lowest Rating (1=low 6=high) in Congo (Democratic)?
Provide a short and direct response. 0.2. What is the difference between the highest and the lowest Rating (1=low 6=high) in Samoa?
Provide a short and direct response. 0.2. 